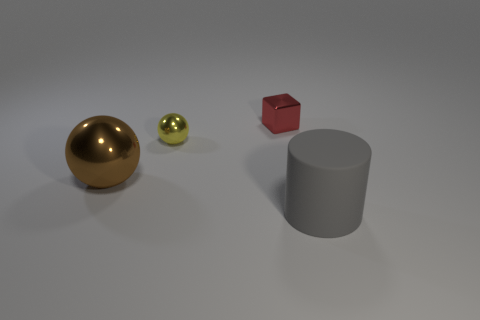Are there an equal number of small yellow balls to the left of the red metal thing and small metallic things that are on the right side of the small yellow sphere?
Your answer should be very brief. Yes. How many other things are made of the same material as the yellow ball?
Give a very brief answer. 2. Is the number of small yellow objects that are behind the yellow sphere the same as the number of green cylinders?
Offer a terse response. Yes. Is the size of the brown metal object the same as the ball that is behind the large brown metallic ball?
Provide a short and direct response. No. What shape is the metallic object right of the small ball?
Make the answer very short. Cube. Is there any other thing that is the same shape as the red metal object?
Your answer should be compact. No. Are there any big purple rubber cubes?
Your answer should be compact. No. Does the ball that is in front of the small yellow shiny ball have the same size as the metallic ball behind the large shiny sphere?
Make the answer very short. No. What material is the thing that is to the left of the large gray cylinder and to the right of the yellow object?
Your answer should be very brief. Metal. There is a gray matte cylinder; what number of spheres are to the right of it?
Provide a short and direct response. 0. 